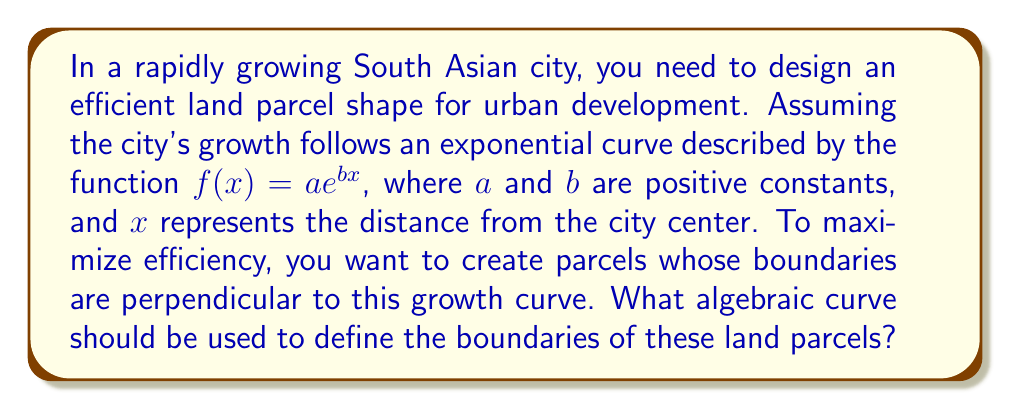Help me with this question. 1) The growth curve is given by $f(x) = ae^{bx}$.

2) To find the curve perpendicular to this growth curve, we need to find its orthogonal trajectory.

3) The slope of the growth curve is given by its derivative:
   $$f'(x) = abe^{bx}$$

4) The slope of the perpendicular curve at any point will be the negative reciprocal of this slope:
   $$m_{\perp} = -\frac{1}{f'(x)} = -\frac{1}{abe^{bx}}$$

5) We can express this as a differential equation:
   $$\frac{dy}{dx} = -\frac{1}{abe^{bx}}$$

6) Separating variables:
   $$dy = -\frac{1}{abe^{bx}}dx$$

7) Integrating both sides:
   $$\int dy = -\int \frac{1}{abe^{bx}}dx$$

8) Solving the integral:
   $$y = \frac{1}{ab}e^{-bx} + C$$

9) This can be rewritten as:
   $$ye^{bx} = \frac{1}{ab} + Ce^{bx}$$

10) Let $k = \frac{1}{ab}$ and $C' = C$, we get:
    $$ye^{bx} = k + C'e^{bx}$$

This is the general form of the orthogonal trajectory, which represents the optimal boundary curve for the land parcels.
Answer: $ye^{bx} = k + C'e^{bx}$, where $k$ and $C'$ are constants 